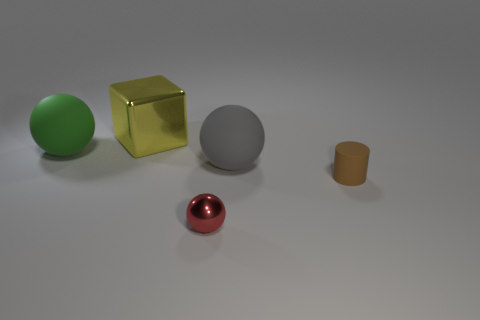Is the size of the green matte thing in front of the yellow object the same as the rubber object right of the gray rubber sphere?
Offer a terse response. No. How many brown cylinders are made of the same material as the big gray sphere?
Keep it short and to the point. 1. What color is the small cylinder?
Provide a short and direct response. Brown. Are there any red balls to the left of the big metallic block?
Make the answer very short. No. Do the metal sphere and the small matte object have the same color?
Provide a short and direct response. No. How many things have the same color as the rubber cylinder?
Provide a succinct answer. 0. There is a matte sphere that is to the left of the shiny thing that is in front of the large green matte ball; how big is it?
Provide a short and direct response. Large. What is the shape of the small brown thing?
Your response must be concise. Cylinder. There is a tiny object that is in front of the cylinder; what is it made of?
Offer a terse response. Metal. There is a shiny object behind the big sphere right of the matte object on the left side of the yellow cube; what is its color?
Make the answer very short. Yellow. 